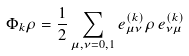Convert formula to latex. <formula><loc_0><loc_0><loc_500><loc_500>\Phi _ { k } \rho = \frac { 1 } { 2 } \sum _ { \mu , \nu = 0 , 1 } e ^ { ( k ) } _ { \mu \nu } \rho \, e ^ { ( k ) } _ { \nu \mu }</formula> 